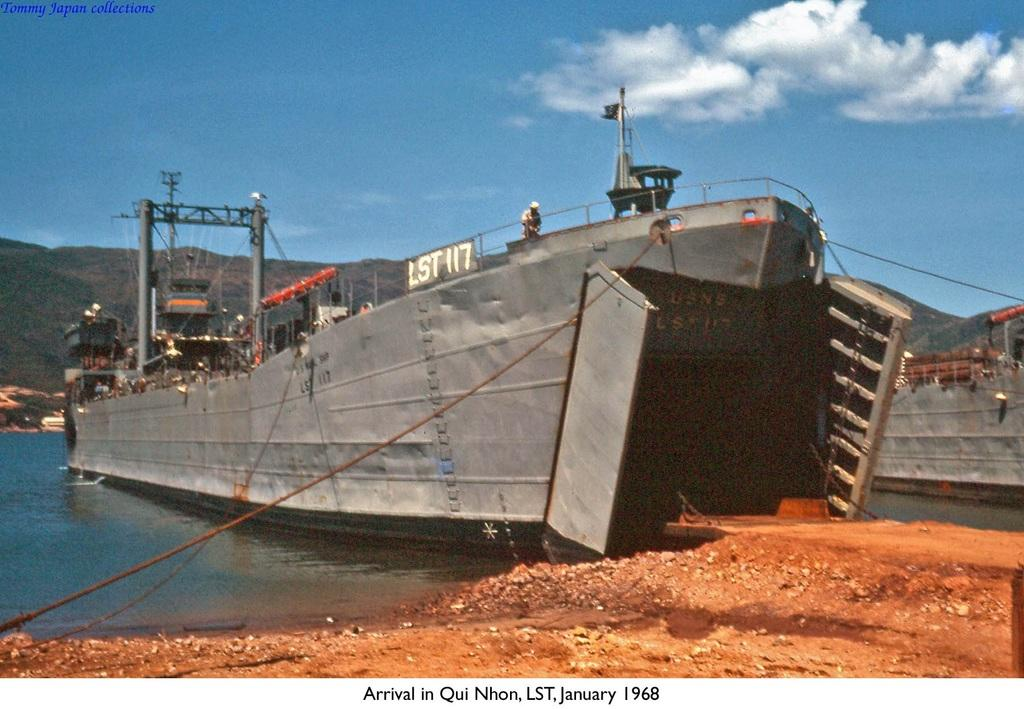What is located on the right side of the image? There is ground on the right side of the image. What can be seen in the background of the image? There are ships parked on the water and a mountain visible in the background of the image. What is the color of the sky in the background of the image? The sky in the background of the image is blue, and there are clouds present. What type of insurance policy is being discussed by the frogs on the mountain in the image? There are no frogs present in the image, and no discussion about insurance policies can be observed. What type of trade is being conducted between the ships in the image? The image does not provide any information about the trade being conducted between the ships; it only shows them parked on the water. 